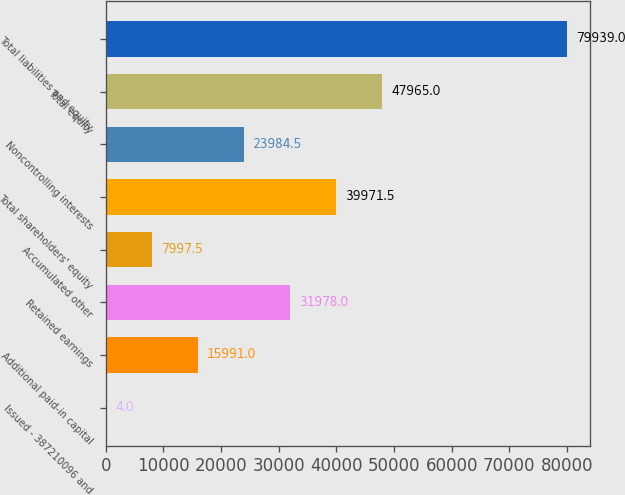Convert chart. <chart><loc_0><loc_0><loc_500><loc_500><bar_chart><fcel>Issued - 387210096 and<fcel>Additional paid-in capital<fcel>Retained earnings<fcel>Accumulated other<fcel>Total shareholders' equity<fcel>Noncontrolling interests<fcel>Total equity<fcel>Total liabilities and equity<nl><fcel>4<fcel>15991<fcel>31978<fcel>7997.5<fcel>39971.5<fcel>23984.5<fcel>47965<fcel>79939<nl></chart> 